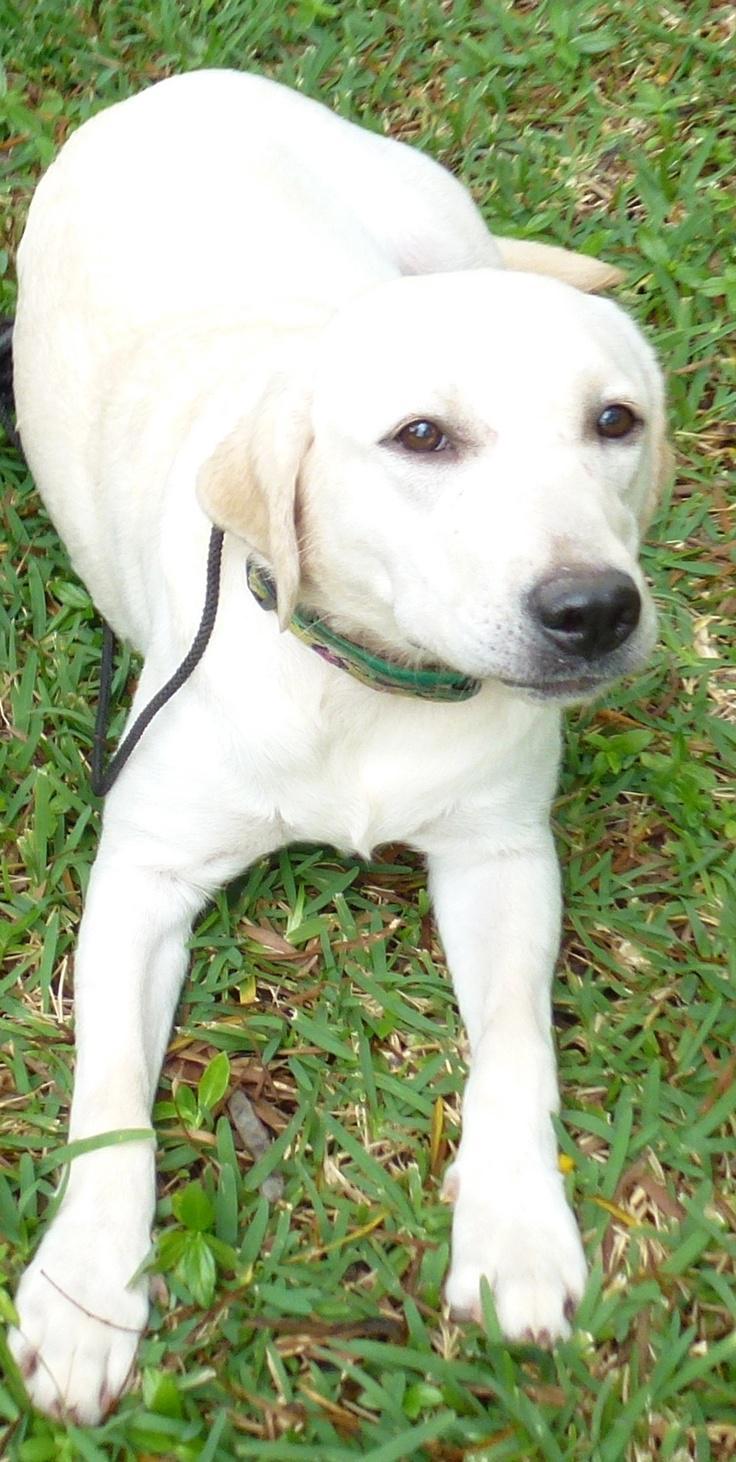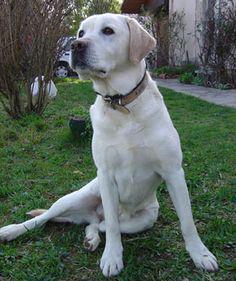The first image is the image on the left, the second image is the image on the right. For the images shown, is this caption "There are three dogs in total." true? Answer yes or no. No. The first image is the image on the left, the second image is the image on the right. Analyze the images presented: Is the assertion "An image contains exactly two dogs." valid? Answer yes or no. No. 